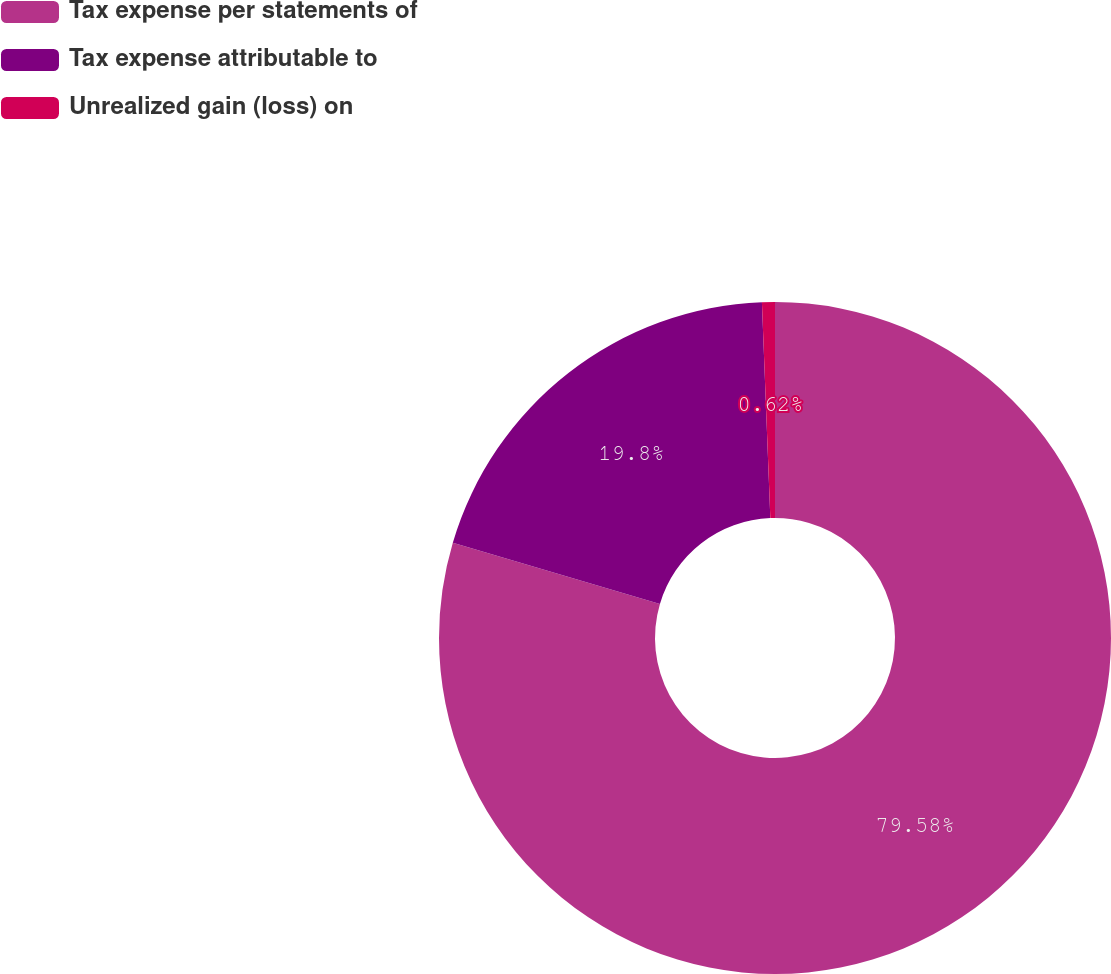Convert chart to OTSL. <chart><loc_0><loc_0><loc_500><loc_500><pie_chart><fcel>Tax expense per statements of<fcel>Tax expense attributable to<fcel>Unrealized gain (loss) on<nl><fcel>79.58%<fcel>19.8%<fcel>0.62%<nl></chart> 